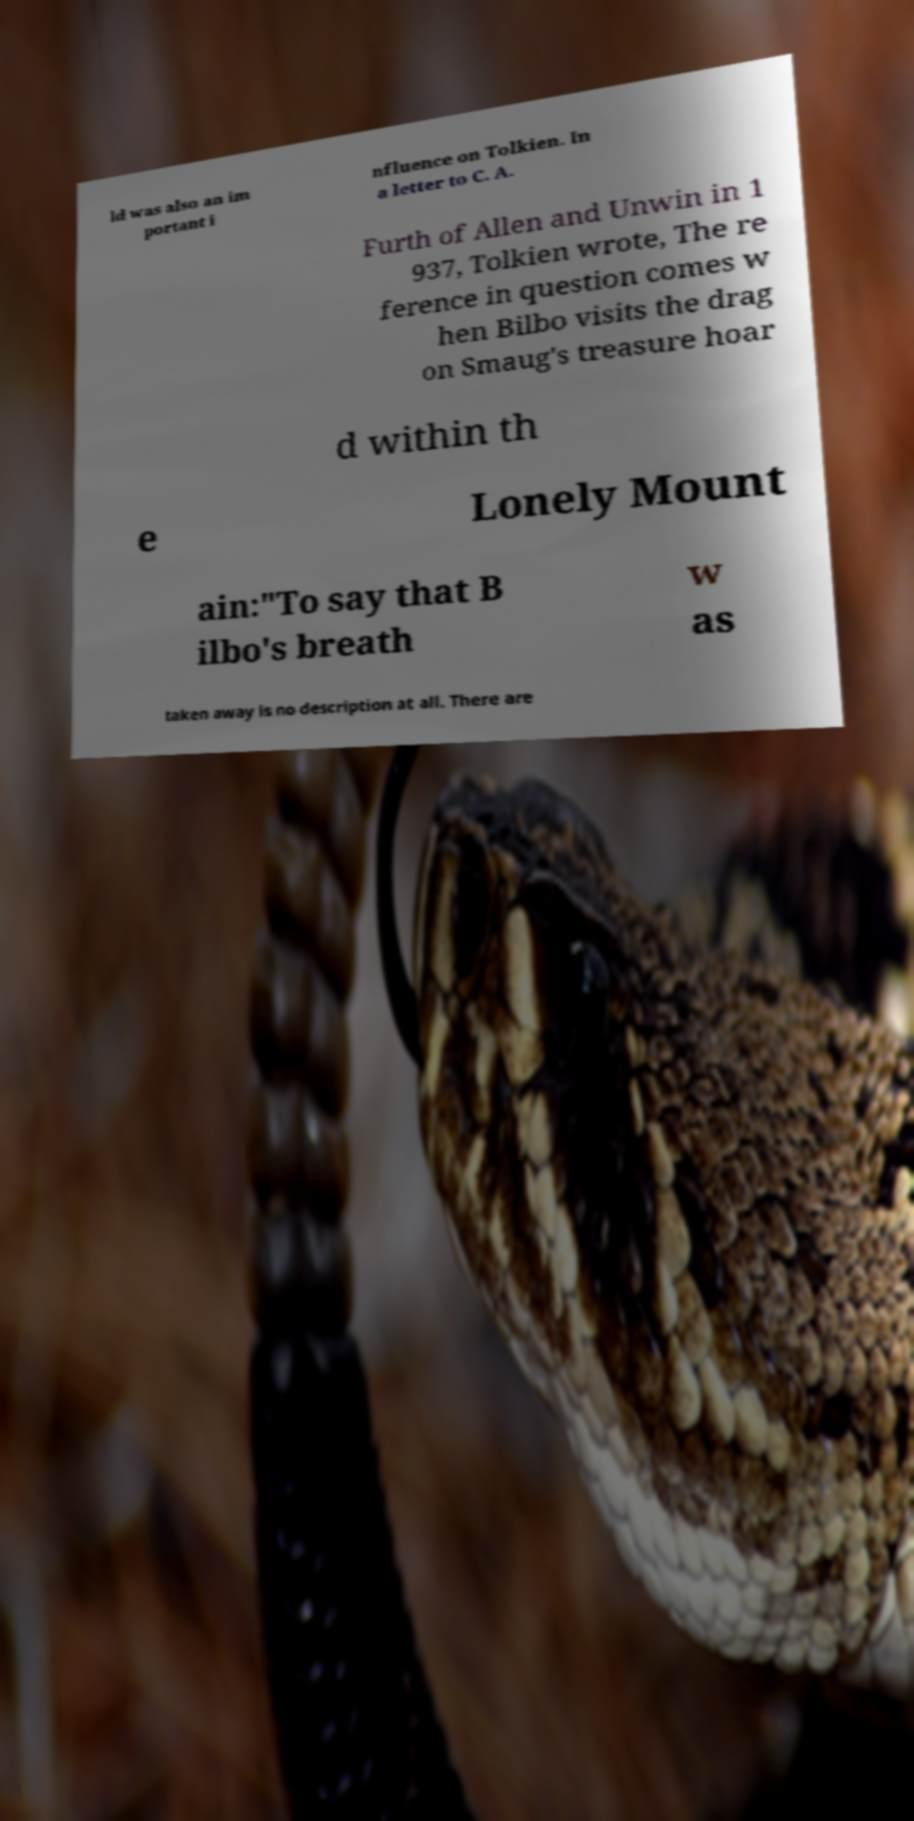Could you extract and type out the text from this image? ld was also an im portant i nfluence on Tolkien. In a letter to C. A. Furth of Allen and Unwin in 1 937, Tolkien wrote, The re ference in question comes w hen Bilbo visits the drag on Smaug's treasure hoar d within th e Lonely Mount ain:"To say that B ilbo's breath w as taken away is no description at all. There are 